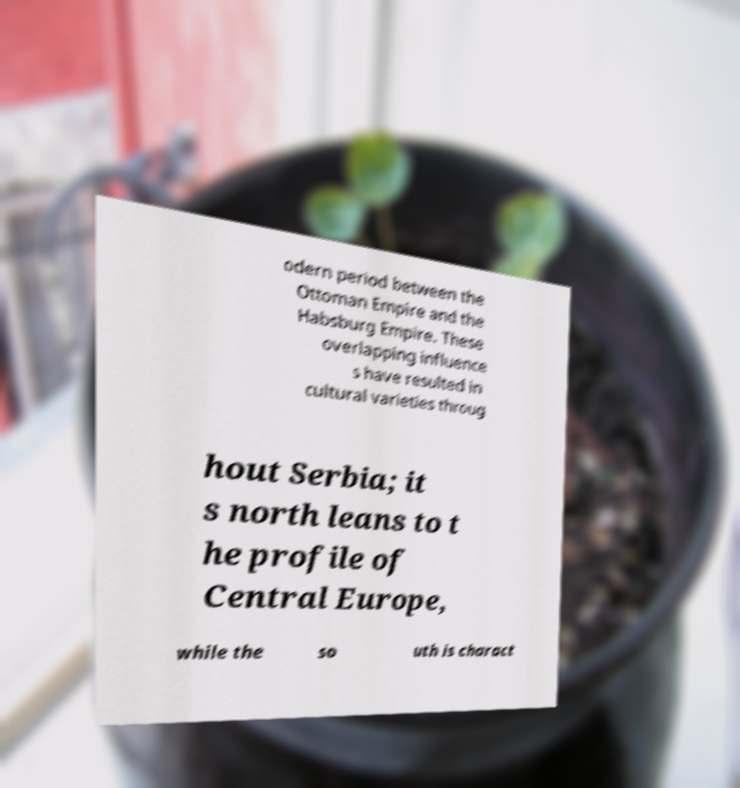Can you read and provide the text displayed in the image?This photo seems to have some interesting text. Can you extract and type it out for me? odern period between the Ottoman Empire and the Habsburg Empire. These overlapping influence s have resulted in cultural varieties throug hout Serbia; it s north leans to t he profile of Central Europe, while the so uth is charact 